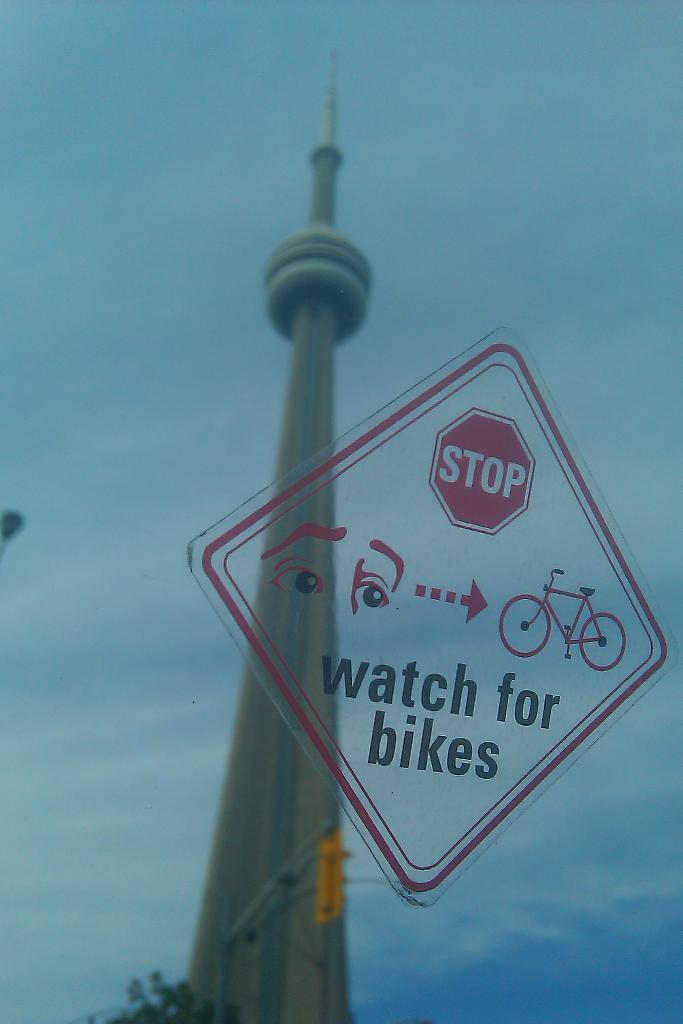What object can be seen in the image that is typically used for drinking? There is a glass in the image. What is on the glass in the image? There is a sticker on the glass. What colors are used on the sticker? The sticker is in red and black colors. What can be seen in the background of the image? There is a tower and clouds in the sky in the background of the image. What type of brain can be seen in the image? There is no brain present in the image. Is there a ball being used in the image? There is no ball present in the image. 